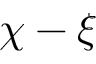Convert formula to latex. <formula><loc_0><loc_0><loc_500><loc_500>\chi - \xi</formula> 